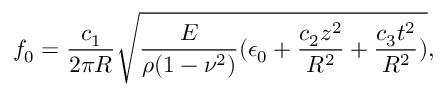Convert formula to latex. <formula><loc_0><loc_0><loc_500><loc_500>f _ { 0 } = \frac { c _ { 1 } } { 2 \pi R } \sqrt { \frac { E } { \rho ( 1 - \nu ^ { 2 } ) } ( \epsilon _ { 0 } + \frac { c _ { 2 } z ^ { 2 } } { R ^ { 2 } } + \frac { c _ { 3 } t ^ { 2 } } { R ^ { 2 } } ) } ,</formula> 